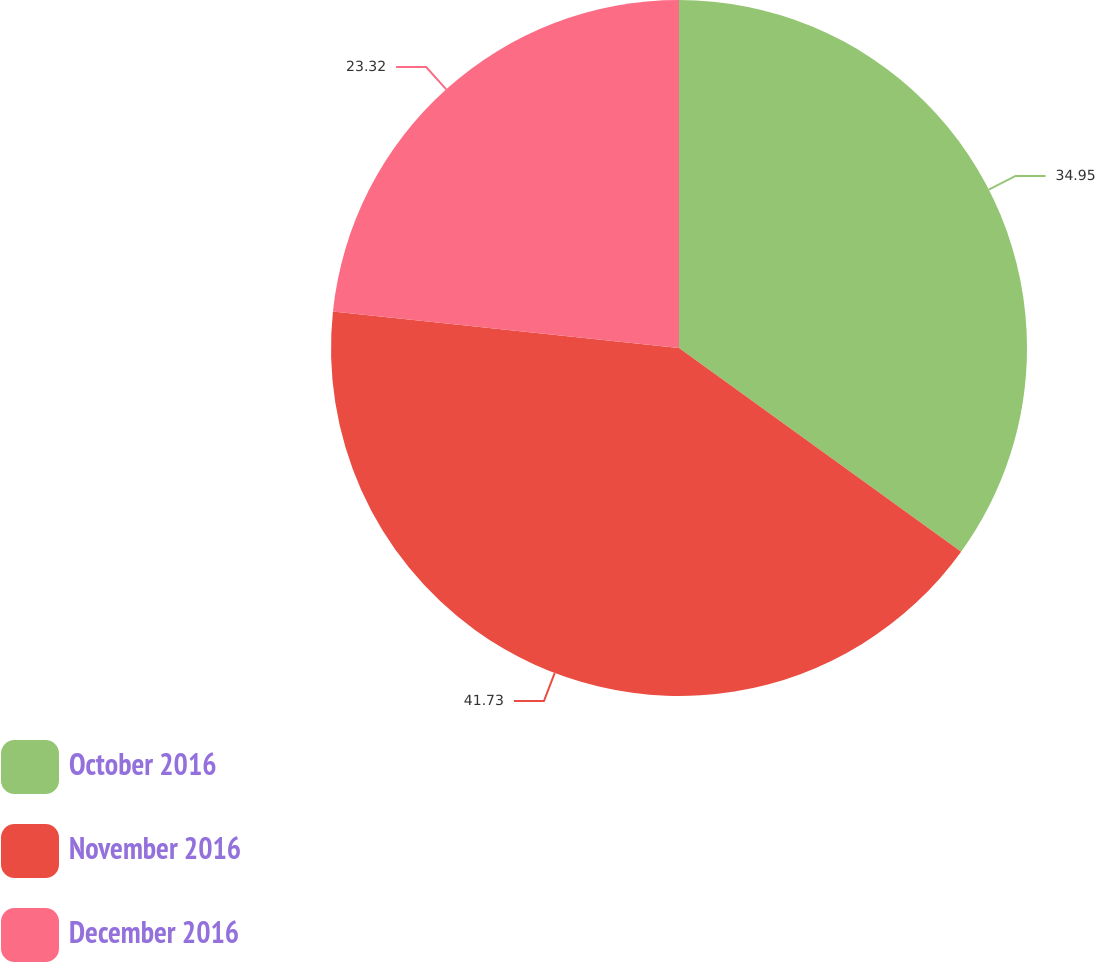<chart> <loc_0><loc_0><loc_500><loc_500><pie_chart><fcel>October 2016<fcel>November 2016<fcel>December 2016<nl><fcel>34.95%<fcel>41.72%<fcel>23.32%<nl></chart> 